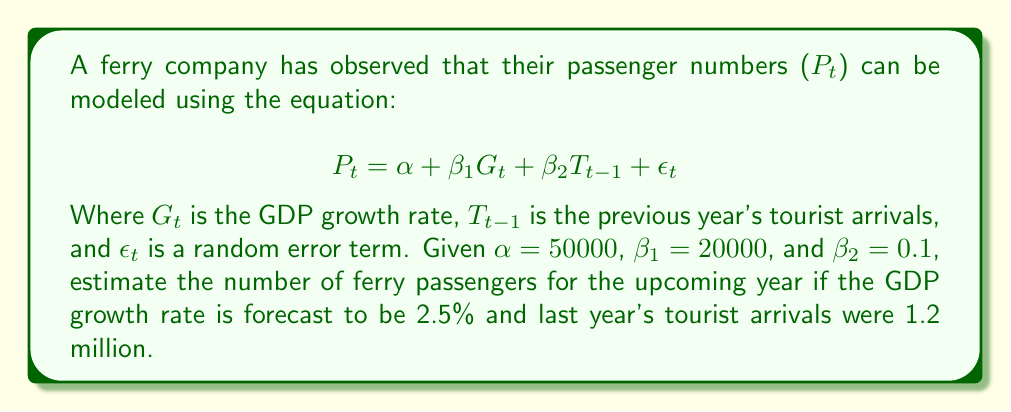Solve this math problem. To solve this inverse problem and predict future ferry demand, we'll use the given equation and values:

1. Start with the equation:
   $$P_t = \alpha + \beta_1 G_t + \beta_2 T_{t-1} + \epsilon_t$$

2. Substitute the known values:
   $\alpha = 50000$
   $\beta_1 = 20000$
   $\beta_2 = 0.1$
   $G_t = 2.5\%$ (GDP growth rate)
   $T_{t-1} = 1200000$ (previous year's tourist arrivals)

3. Ignore the error term $\epsilon_t$ for prediction purposes:
   $$P_t = 50000 + 20000 \cdot G_t + 0.1 \cdot T_{t-1}$$

4. Convert the GDP growth rate to decimal form:
   $2.5\% = 0.025$

5. Substitute the values into the equation:
   $$P_t = 50000 + 20000 \cdot 0.025 + 0.1 \cdot 1200000$$

6. Calculate each term:
   $$P_t = 50000 + 500 + 120000$$

7. Sum up the terms:
   $$P_t = 170500$$

Therefore, the estimated number of ferry passengers for the upcoming year is 170,500.
Answer: 170,500 passengers 